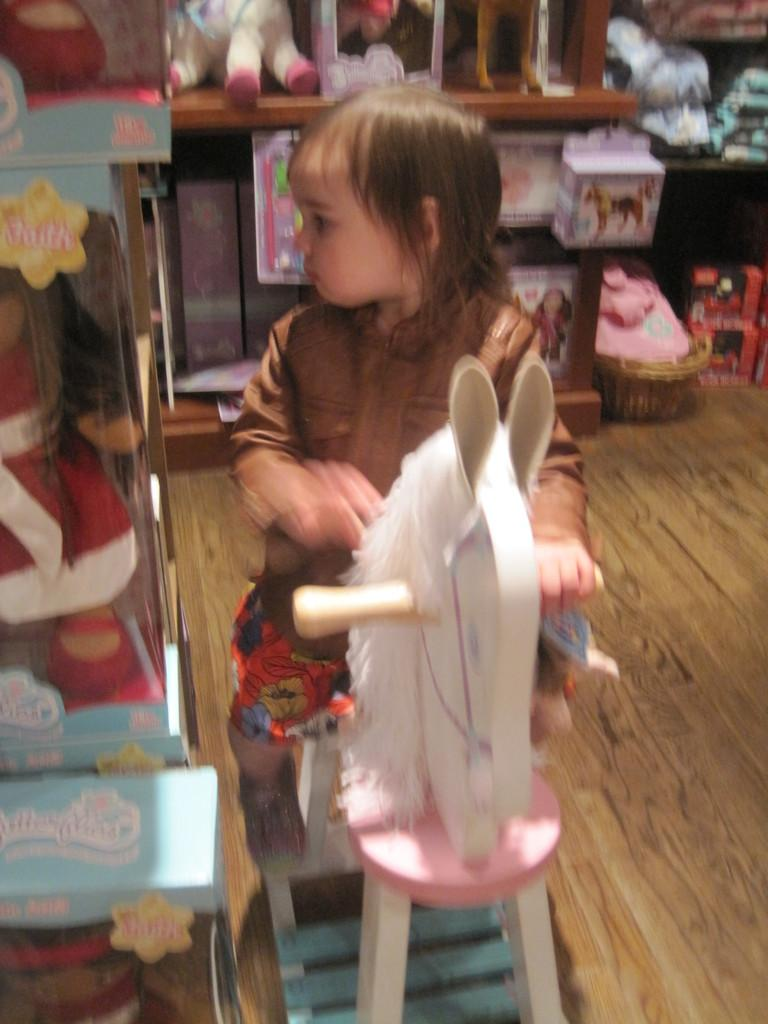What is the main subject of the image? The main subject of the image is a kid. What is the kid doing in the image? The kid is sitting on a horse cart. Are there any other objects or toys visible in the image? Yes, there are other toys on a table in the image. What grade does the horse cart receive for its performance in the image? There is no indication of a grade or performance evaluation in the image, as it is a still photograph. 